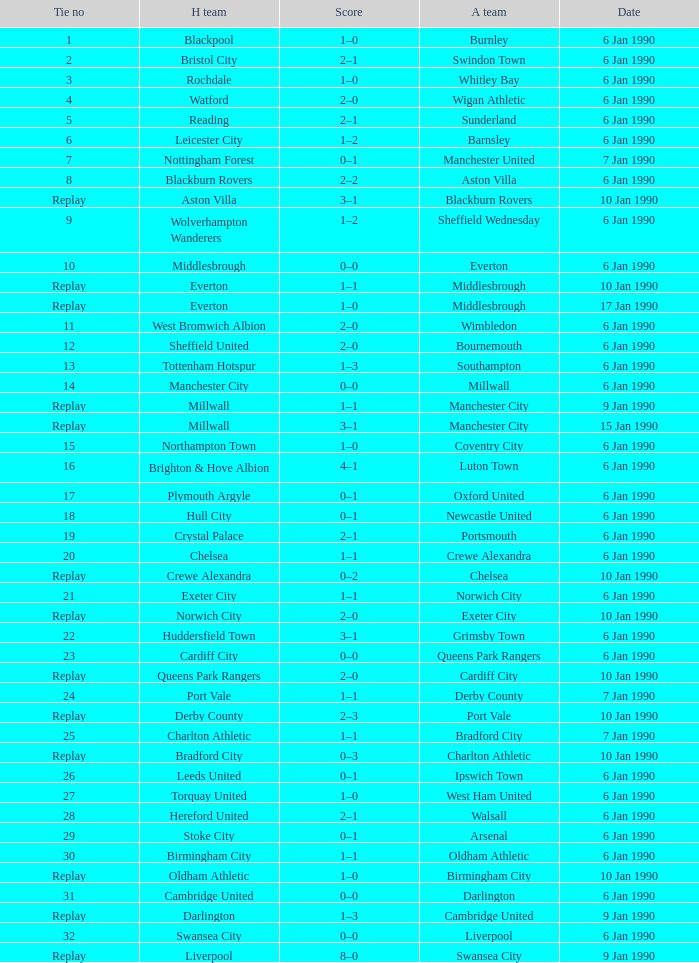What was the score of the game against away team crewe alexandra? 1–1. 